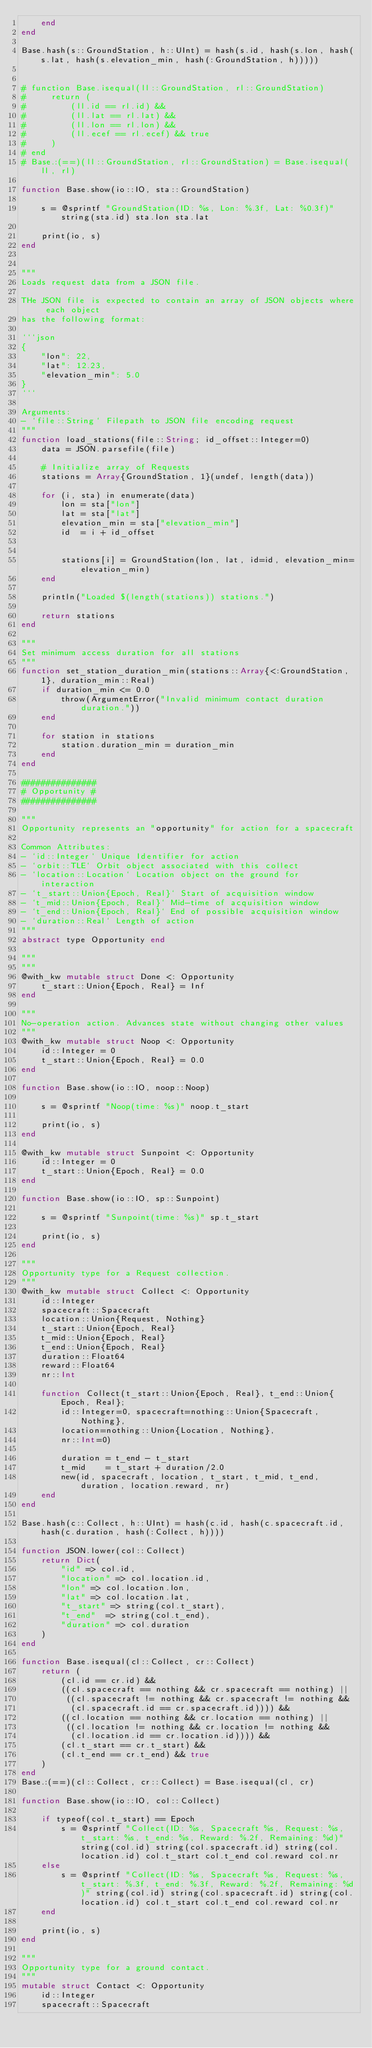<code> <loc_0><loc_0><loc_500><loc_500><_Julia_>    end
end

Base.hash(s::GroundStation, h::UInt) = hash(s.id, hash(s.lon, hash(s.lat, hash(s.elevation_min, hash(:GroundStation, h)))))


# function Base.isequal(ll::GroundStation, rl::GroundStation)
#     return (
#         (ll.id == rl.id) &&
#         (ll.lat == rl.lat) &&
#         (ll.lon == rl.lon) &&
#         (ll.ecef == rl.ecef) && true
#     )
# end
# Base.:(==)(ll::GroundStation, rl::GroundStation) = Base.isequal(ll, rl)

function Base.show(io::IO, sta::GroundStation)

    s = @sprintf "GroundStation(ID: %s, Lon: %.3f, Lat: %0.3f)" string(sta.id) sta.lon sta.lat

    print(io, s)
end


"""
Loads request data from a JSON file.

THe JSON file is expected to contain an array of JSON objects where each object 
has the following format:

```json
{
    "lon": 22,
    "lat": 12.23,
    "elevation_min": 5.0
}
```

Arguments:
- `file::String` Filepath to JSON file encoding request 
"""
function load_stations(file::String; id_offset::Integer=0)
    data = JSON.parsefile(file)

    # Initialize array of Requests
    stations = Array{GroundStation, 1}(undef, length(data))

    for (i, sta) in enumerate(data)
        lon = sta["lon"]
        lat = sta["lat"]
        elevation_min = sta["elevation_min"]
        id  = i + id_offset


        stations[i] = GroundStation(lon, lat, id=id, elevation_min=elevation_min)
    end

    println("Loaded $(length(stations)) stations.")

    return stations
end

"""
Set minimum access duration for all stations
"""
function set_station_duration_min(stations::Array{<:GroundStation, 1}, duration_min::Real)
    if duration_min <= 0.0
        throw(ArgumentError("Invalid minimum contact duration duration."))
    end

    for station in stations
        station.duration_min = duration_min
    end
end

###############
# Opportunity #
###############

"""
Opportunity represents an "opportunity" for action for a spacecraft

Common Attributes:
- `id::Integer` Unique Identifier for action
- `orbit::TLE` Orbit object associated with this collect
- `location::Location` Location object on the ground for interaction
- `t_start::Union{Epoch, Real}` Start of acquisition window 
- `t_mid::Union{Epoch, Real}` Mid-time of acquisition window
- `t_end::Union{Epoch, Real}` End of possible acquisition window
- `duration::Real` Length of action
"""
abstract type Opportunity end

"""
"""
@with_kw mutable struct Done <: Opportunity
    t_start::Union{Epoch, Real} = Inf
end

"""
No-operation action. Advances state without changing other values
"""
@with_kw mutable struct Noop <: Opportunity
    id::Integer = 0
    t_start::Union{Epoch, Real} = 0.0
end

function Base.show(io::IO, noop::Noop)

    s = @sprintf "Noop(time: %s)" noop.t_start

    print(io, s)
end

@with_kw mutable struct Sunpoint <: Opportunity
    id::Integer = 0
    t_start::Union{Epoch, Real} = 0.0
end

function Base.show(io::IO, sp::Sunpoint)

    s = @sprintf "Sunpoint(time: %s)" sp.t_start

    print(io, s)
end

"""
Opportunity type for a Request collection.
"""
@with_kw mutable struct Collect <: Opportunity
    id::Integer
    spacecraft::Spacecraft
    location::Union{Request, Nothing}
    t_start::Union{Epoch, Real}
    t_mid::Union{Epoch, Real}
    t_end::Union{Epoch, Real}
    duration::Float64
    reward::Float64
    nr::Int

    function Collect(t_start::Union{Epoch, Real}, t_end::Union{Epoch, Real};
        id::Integer=0, spacecraft=nothing::Union{Spacecraft, Nothing}, 
        location=nothing::Union{Location, Nothing},
        nr::Int=0)

        duration = t_end - t_start
        t_mid    = t_start + duration/2.0
        new(id, spacecraft, location, t_start, t_mid, t_end, duration, location.reward, nr)
    end
end

Base.hash(c::Collect, h::UInt) = hash(c.id, hash(c.spacecraft.id, hash(c.duration, hash(:Collect, h))))

function JSON.lower(col::Collect)
    return Dict(
        "id" => col.id,
        "location" => col.location.id,
        "lon" => col.location.lon,
        "lat" => col.location.lat,
        "t_start" => string(col.t_start),
        "t_end"  => string(col.t_end),
        "duration" => col.duration
    )    
end

function Base.isequal(cl::Collect, cr::Collect)
    return (
        (cl.id == cr.id) &&
        ((cl.spacecraft == nothing && cr.spacecraft == nothing) ||
         ((cl.spacecraft != nothing && cr.spacecraft != nothing &&
          (cl.spacecraft.id == cr.spacecraft.id)))) &&
        ((cl.location == nothing && cr.location == nothing) ||
         ((cl.location != nothing && cr.location != nothing &&
          (cl.location.id == cr.location.id)))) &&
        (cl.t_start == cr.t_start) &&
        (cl.t_end == cr.t_end) && true
    )
end
Base.:(==)(cl::Collect, cr::Collect) = Base.isequal(cl, cr)

function Base.show(io::IO, col::Collect)

    if typeof(col.t_start) == Epoch
        s = @sprintf "Collect(ID: %s, Spacecraft %s, Request: %s, t_start: %s, t_end: %s, Reward: %.2f, Remaining: %d)" string(col.id) string(col.spacecraft.id) string(col.location.id) col.t_start col.t_end col.reward col.nr
    else
        s = @sprintf "Collect(ID: %s, Spacecraft %s, Request: %s, t_start: %.3f, t_end: %.3f, Reward: %.2f, Remaining: %d)" string(col.id) string(col.spacecraft.id) string(col.location.id) col.t_start col.t_end col.reward col.nr
    end

    print(io, s)
end

"""
Opportunity type for a ground contact.
"""
mutable struct Contact <: Opportunity
    id::Integer
    spacecraft::Spacecraft</code> 